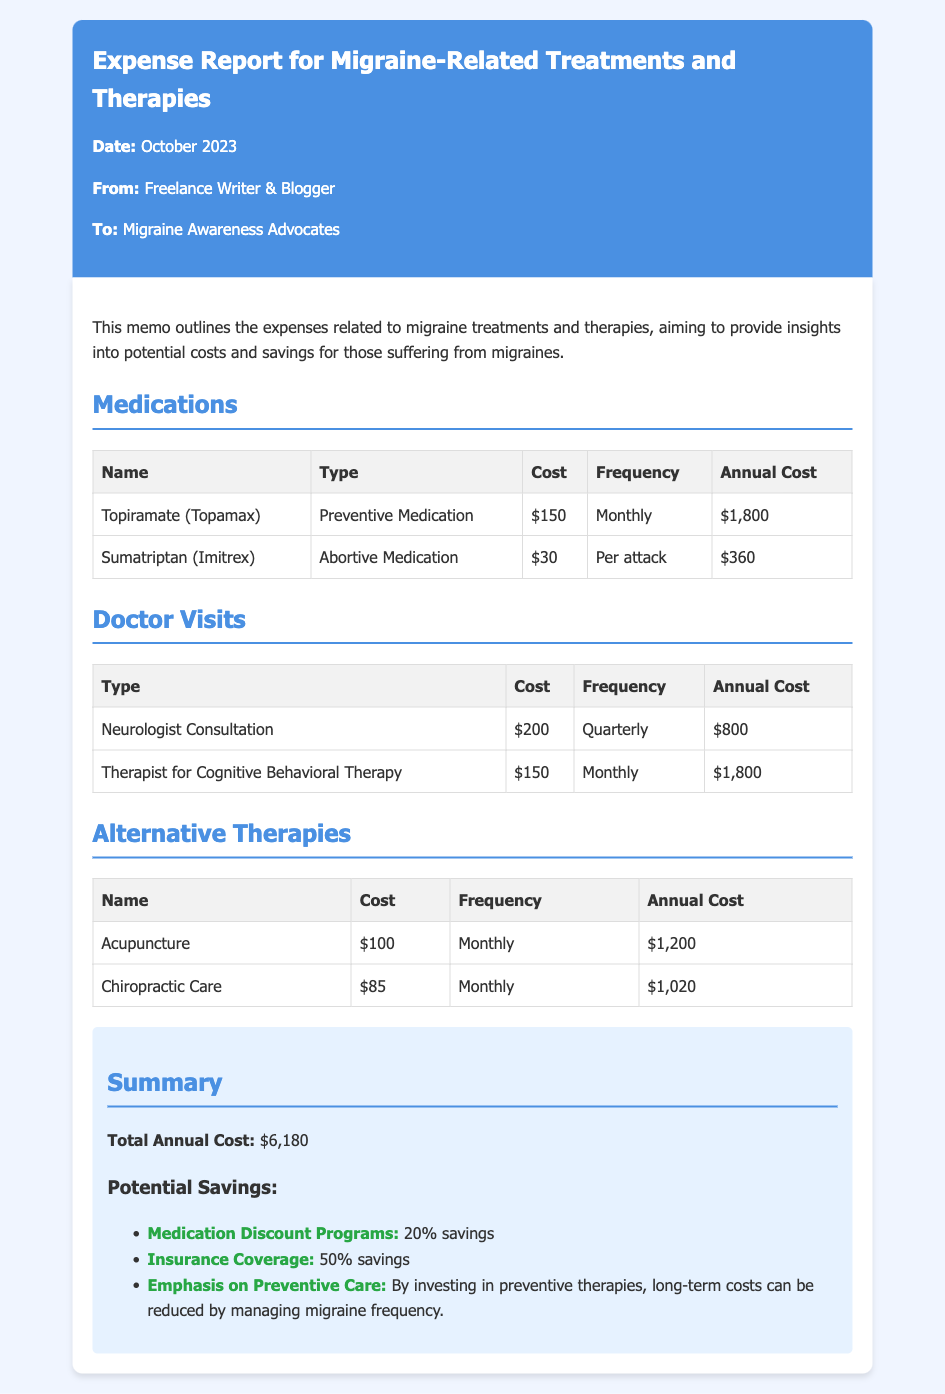what is the total annual cost for migraine-related treatments? The total annual cost is provided in the summary section of the document, which is $6,180.
Answer: $6,180 how much does a neurologist consultation cost? The cost for a neurologist consultation is listed in the doctor visits table, which states $200.
Answer: $200 what is the frequency of therapy for cognitive behavioral therapy? The frequency for cognitive behavioral therapy is provided in the doctor visits table, which indicates monthly.
Answer: Monthly what percentage savings is offered by medication discount programs? The medication discount programs savings percentage is mentioned in the summary section as 20%.
Answer: 20% how much does acupuncture cost per session? The cost for acupuncture per session is given in the alternative therapies table as $100.
Answer: $100 what type of medication is Sumatriptan classified as? The classification of Sumatriptan is found in the medications table, where it is defined as an abortive medication.
Answer: Abortive Medication how often should chiropractic care be received? The frequency for chiropractic care can be found in the alternative therapies table, which specifies monthly.
Answer: Monthly what is the annual cost of Topiramate? The annual cost of Topiramate is detailed in the medications table as $1,800.
Answer: $1,800 what is emphasized for reducing long-term costs in migraine management? The document suggests an emphasis on preventive care in the summary section as a way to reduce long-term costs.
Answer: Preventive Care 